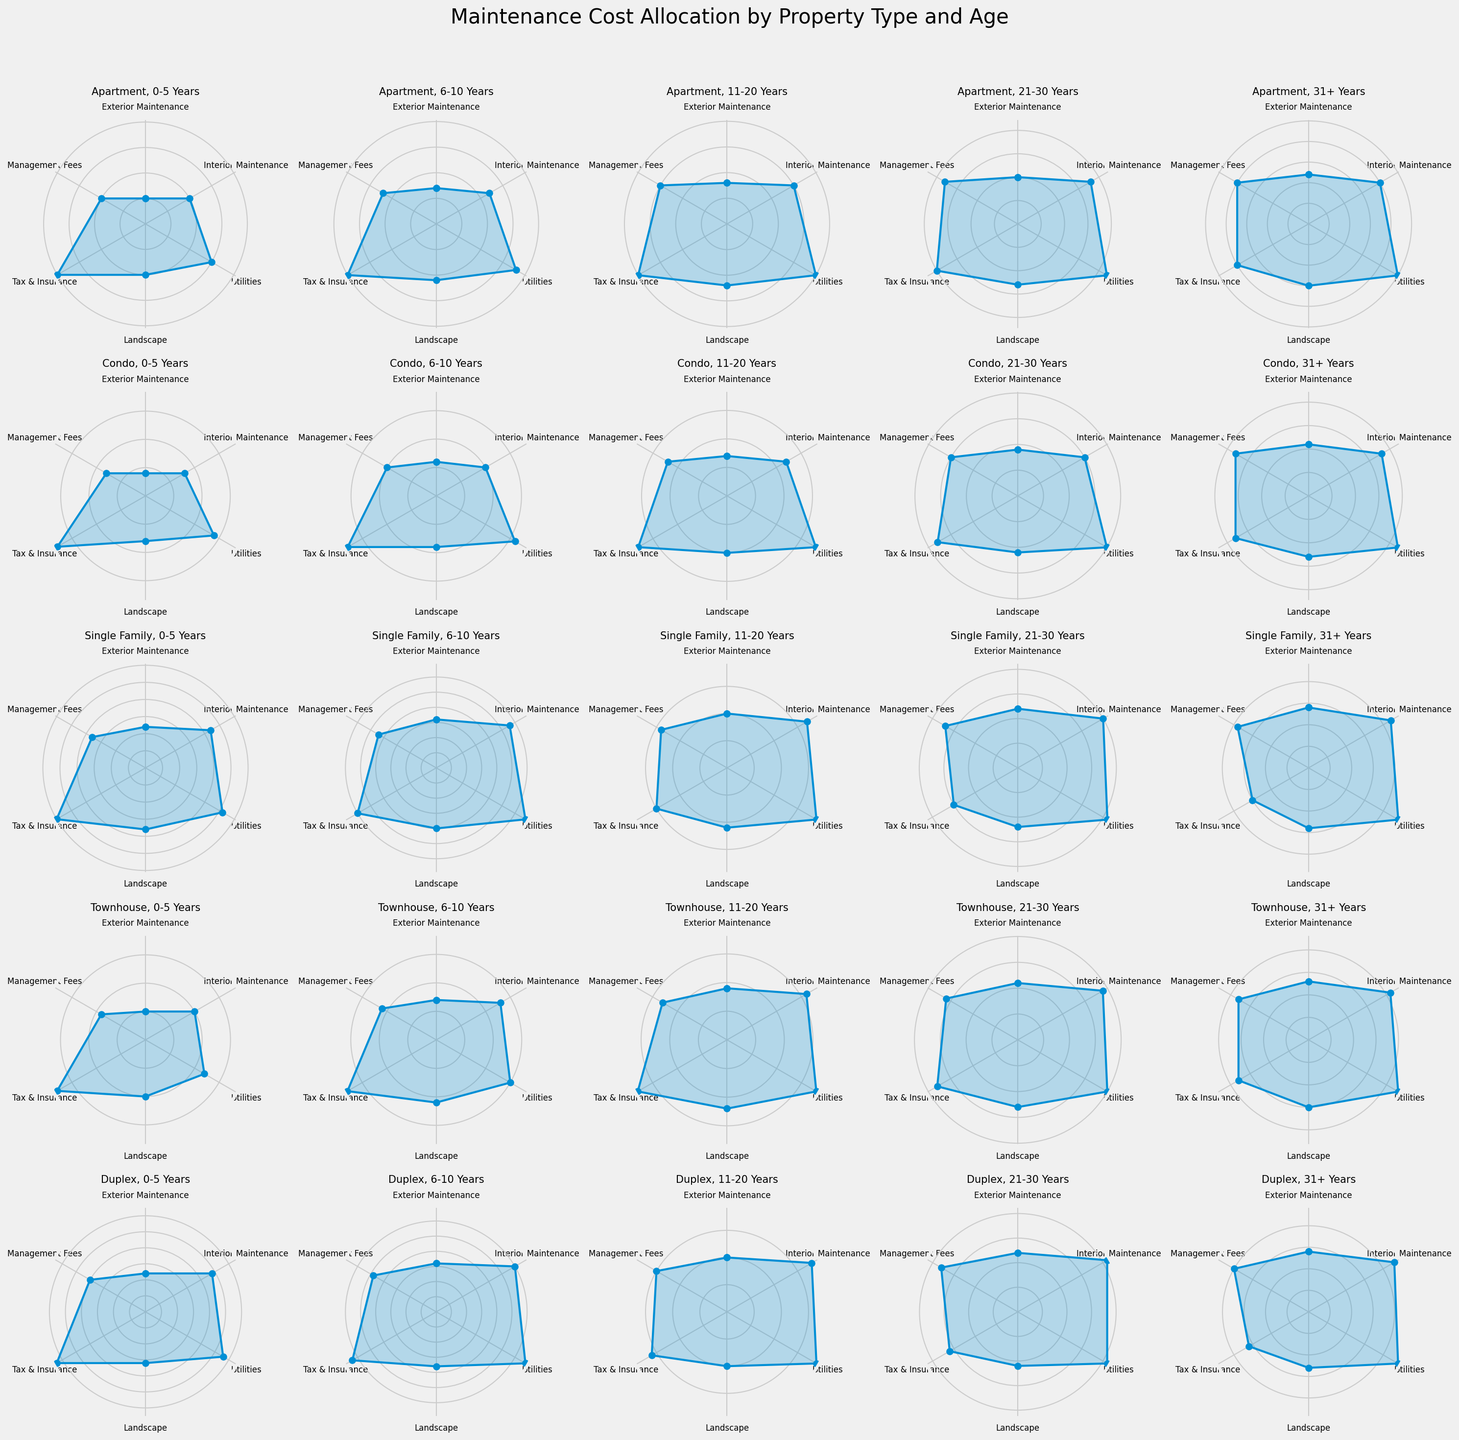What's the most significant maintenance cost category for apartments aged 31+ years? Scan the plot for the apartment segment aged 31+ years and observe the lengths of the segments; the longest segment indicates the most substantial cost. The category 'Utilities' stands out prominently.
Answer: Utilities How does the exterior maintenance cost of single-family houses aged 11-20 years compare to that of condos in the same age group? Examine the plot segments related to exterior maintenance for both single-family and condo properties aged 11-20 years. The single-family plot shows a longer segment for exterior maintenance compared to the condos.
Answer: Greater for single-family houses What is the difference in interior maintenance costs between duplexes and townhouses aged 21-30 years? Identify the interior maintenance segments for both duplex and townhouse properties aged 21-30 years. Duplexes show a value of 21, and townhouses have 19. The difference is 21 - 19.
Answer: 2 Which property type has consistently increasing management fees with age? Observe the trend of management fees across different age groups for each property type. Apartments consistently show an increase from 10 to 20.
Answer: Apartments For condos aged 31+ years, is the landscape cost higher or lower than that of single-family houses aged 0-5 years? Compare the landscape segments for condos aged 31+ years and single-family houses aged 0-5 years. Condos have a value of 13, and single-family houses have 9.
Answer: Higher What is the average utilities cost across all property types aged 21-30 years? Sum the utility values for all property types aged 21-30 years and divide by the number of property types: (22 + 20 + 21 + 20 + 21) / 5.
Answer: 20.8 Which property type has lower landscape costs with increased age, and at what age does this trend change? Observe the landscape cost segments for each property type across all age groups and identify if there's a consistent decrease followed by an increase. Landscape costs in duplex properties decrease initially and then increase starting from 11-20 years.
Answer: Duplex, at 11-20 years What is the combined cost of tax & insurance and management fees for townhouses aged 0-5 years? Add the values of tax & insurance and management fees segments for townhouses aged 0-5 years: 18 + 9.
Answer: 27 Between apartments and townhouses aged 0-5 years, which property type allocates more to interior maintenance, and by how much? Compare the interior maintenance segments for apartments and townhouses aged 0-5 years. Apartments show 10, and townhouses show 10, so the difference is 10 - 10.
Answer: Equal, 0 